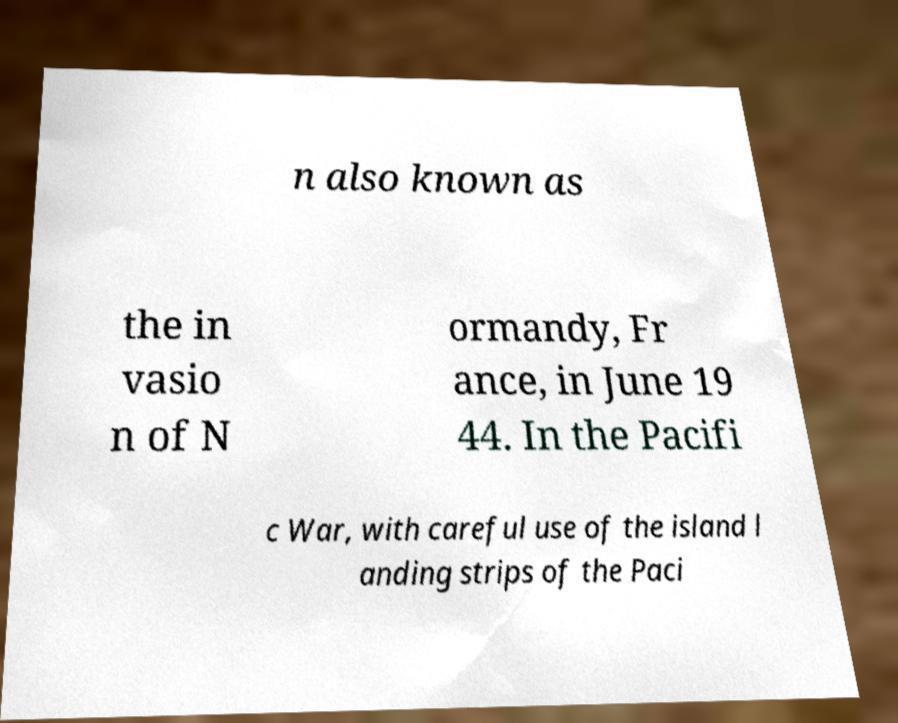Could you extract and type out the text from this image? n also known as the in vasio n of N ormandy, Fr ance, in June 19 44. In the Pacifi c War, with careful use of the island l anding strips of the Paci 